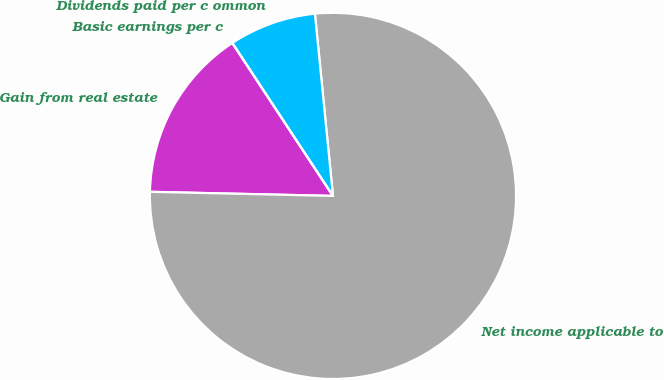<chart> <loc_0><loc_0><loc_500><loc_500><pie_chart><fcel>Gain from real estate<fcel>Net income applicable to<fcel>Dividends paid per c ommon<fcel>Basic earnings per c<nl><fcel>15.38%<fcel>76.92%<fcel>7.69%<fcel>0.0%<nl></chart> 